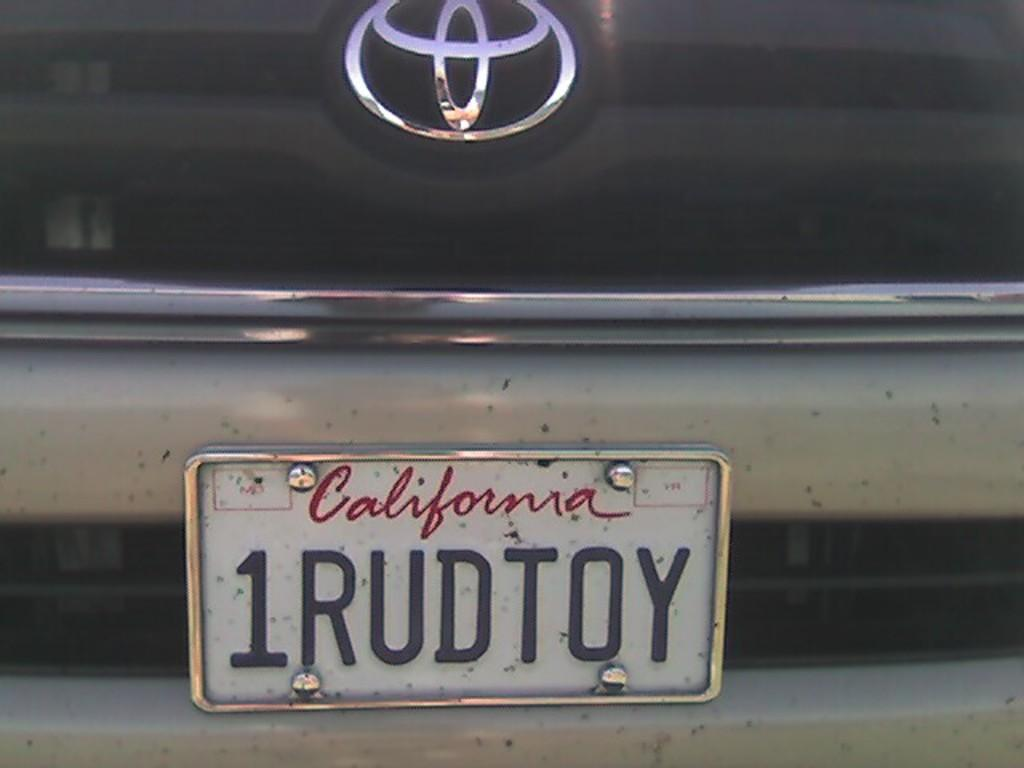<image>
Share a concise interpretation of the image provided. A license plate from California is on a Toyota and read 1RUDTOY. 